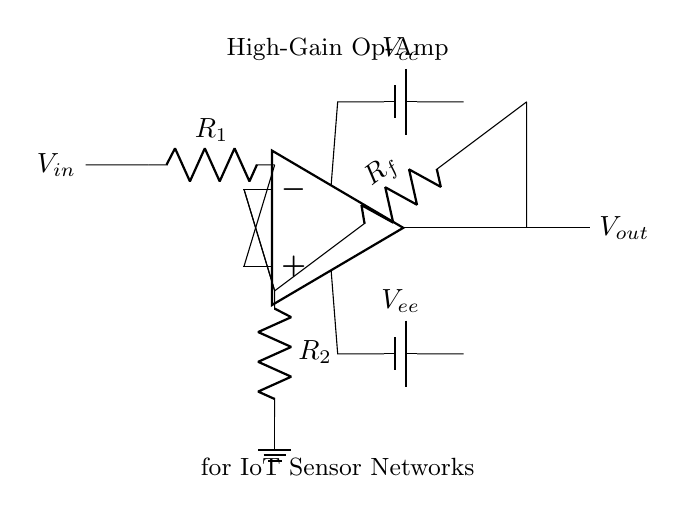What is the input voltage of the circuit? The input voltage is represented as V in the circuit diagram, indicating the voltage applied at the non-inverting terminal of the operational amplifier.
Answer: V in What is the output voltage of the circuit? The output voltage is denoted as V out, which is the voltage taken from the output of the operational amplifier after amplification.
Answer: V out What type of resistors are present in the circuit? The circuit contains three resistors labeled R1, R2, and Rf, which are used to set the gain and establish feedback within the circuit.
Answer: R1, R2, Rf What is the purpose of Rf in the circuit? Rf is the feedback resistor that determines the gain of the operational amplifier by forming a voltage divider with R1. Its value influences how much of the output voltage is fed back to the inverting input.
Answer: Gain control What happens to the output voltage if Rf is increased? If Rf is increased, the feedback ratio decreases, which results in a higher gain according to the formula for an inverting amplifier, causing a larger output voltage for a given input voltage.
Answer: Higher gain How are the power supplies connected to the op-amp? The op-amp is connected to dual power supplies, V cc and V ee, where V cc is positive and V ee is negative, ensuring proper operation of the amplifier within its required voltage range.
Answer: Dual power supplies What role does the operational amplifier play in this circuit? The operational amplifier amplifies the input signal and enhances its strength, making it suitable for interfacing with various sensors in IoT applications, thereby improving signal quality and processing.
Answer: Signal amplification 